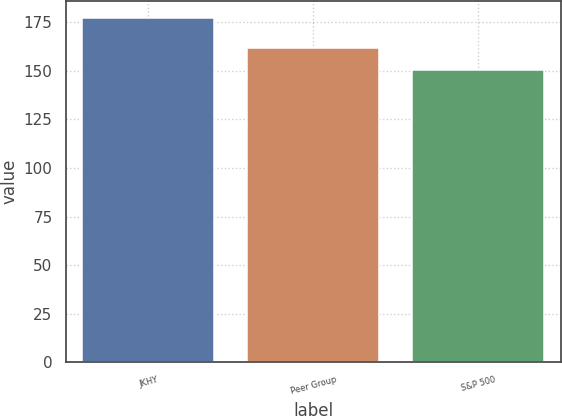Convert chart to OTSL. <chart><loc_0><loc_0><loc_500><loc_500><bar_chart><fcel>JKHY<fcel>Peer Group<fcel>S&P 500<nl><fcel>177.1<fcel>161.9<fcel>150.27<nl></chart> 